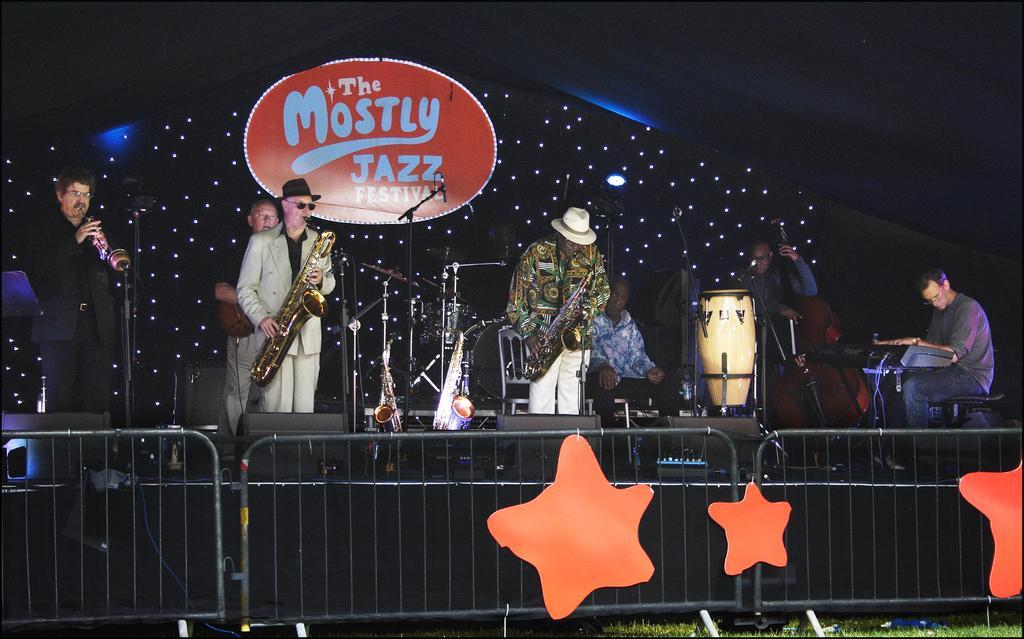Could you give a brief overview of what you see in this image? Here we can see a few people of music band performing on a stage. They are playing a saxophone, playing a guitar and playing a piano. 